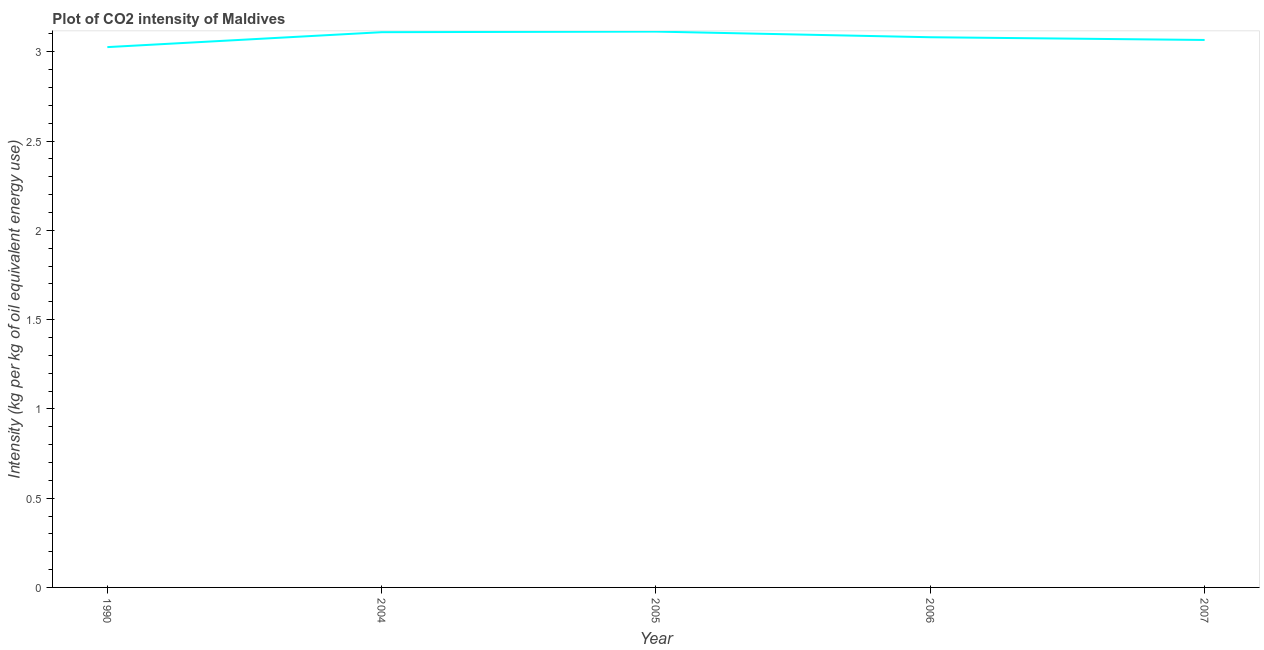What is the co2 intensity in 2006?
Provide a short and direct response. 3.08. Across all years, what is the maximum co2 intensity?
Make the answer very short. 3.11. Across all years, what is the minimum co2 intensity?
Make the answer very short. 3.03. In which year was the co2 intensity maximum?
Your answer should be very brief. 2005. In which year was the co2 intensity minimum?
Your response must be concise. 1990. What is the sum of the co2 intensity?
Offer a terse response. 15.4. What is the difference between the co2 intensity in 2004 and 2006?
Your answer should be compact. 0.03. What is the average co2 intensity per year?
Provide a short and direct response. 3.08. What is the median co2 intensity?
Ensure brevity in your answer.  3.08. In how many years, is the co2 intensity greater than 1 kg?
Keep it short and to the point. 5. What is the ratio of the co2 intensity in 1990 to that in 2006?
Your answer should be very brief. 0.98. What is the difference between the highest and the second highest co2 intensity?
Your response must be concise. 0. Is the sum of the co2 intensity in 2005 and 2007 greater than the maximum co2 intensity across all years?
Offer a very short reply. Yes. What is the difference between the highest and the lowest co2 intensity?
Offer a terse response. 0.09. Does the co2 intensity monotonically increase over the years?
Offer a terse response. No. How many years are there in the graph?
Offer a terse response. 5. Does the graph contain grids?
Give a very brief answer. No. What is the title of the graph?
Provide a short and direct response. Plot of CO2 intensity of Maldives. What is the label or title of the X-axis?
Offer a very short reply. Year. What is the label or title of the Y-axis?
Your answer should be compact. Intensity (kg per kg of oil equivalent energy use). What is the Intensity (kg per kg of oil equivalent energy use) of 1990?
Make the answer very short. 3.03. What is the Intensity (kg per kg of oil equivalent energy use) in 2004?
Give a very brief answer. 3.11. What is the Intensity (kg per kg of oil equivalent energy use) in 2005?
Give a very brief answer. 3.11. What is the Intensity (kg per kg of oil equivalent energy use) of 2006?
Offer a terse response. 3.08. What is the Intensity (kg per kg of oil equivalent energy use) in 2007?
Offer a terse response. 3.07. What is the difference between the Intensity (kg per kg of oil equivalent energy use) in 1990 and 2004?
Keep it short and to the point. -0.08. What is the difference between the Intensity (kg per kg of oil equivalent energy use) in 1990 and 2005?
Provide a succinct answer. -0.09. What is the difference between the Intensity (kg per kg of oil equivalent energy use) in 1990 and 2006?
Offer a very short reply. -0.06. What is the difference between the Intensity (kg per kg of oil equivalent energy use) in 1990 and 2007?
Ensure brevity in your answer.  -0.04. What is the difference between the Intensity (kg per kg of oil equivalent energy use) in 2004 and 2005?
Your answer should be very brief. -0. What is the difference between the Intensity (kg per kg of oil equivalent energy use) in 2004 and 2006?
Offer a very short reply. 0.03. What is the difference between the Intensity (kg per kg of oil equivalent energy use) in 2004 and 2007?
Offer a very short reply. 0.04. What is the difference between the Intensity (kg per kg of oil equivalent energy use) in 2005 and 2006?
Ensure brevity in your answer.  0.03. What is the difference between the Intensity (kg per kg of oil equivalent energy use) in 2005 and 2007?
Your response must be concise. 0.05. What is the difference between the Intensity (kg per kg of oil equivalent energy use) in 2006 and 2007?
Make the answer very short. 0.02. What is the ratio of the Intensity (kg per kg of oil equivalent energy use) in 1990 to that in 2004?
Offer a terse response. 0.97. What is the ratio of the Intensity (kg per kg of oil equivalent energy use) in 1990 to that in 2006?
Your response must be concise. 0.98. What is the ratio of the Intensity (kg per kg of oil equivalent energy use) in 1990 to that in 2007?
Offer a terse response. 0.99. What is the ratio of the Intensity (kg per kg of oil equivalent energy use) in 2004 to that in 2005?
Your answer should be very brief. 1. What is the ratio of the Intensity (kg per kg of oil equivalent energy use) in 2004 to that in 2007?
Keep it short and to the point. 1.01. What is the ratio of the Intensity (kg per kg of oil equivalent energy use) in 2005 to that in 2007?
Give a very brief answer. 1.01. What is the ratio of the Intensity (kg per kg of oil equivalent energy use) in 2006 to that in 2007?
Your answer should be compact. 1. 